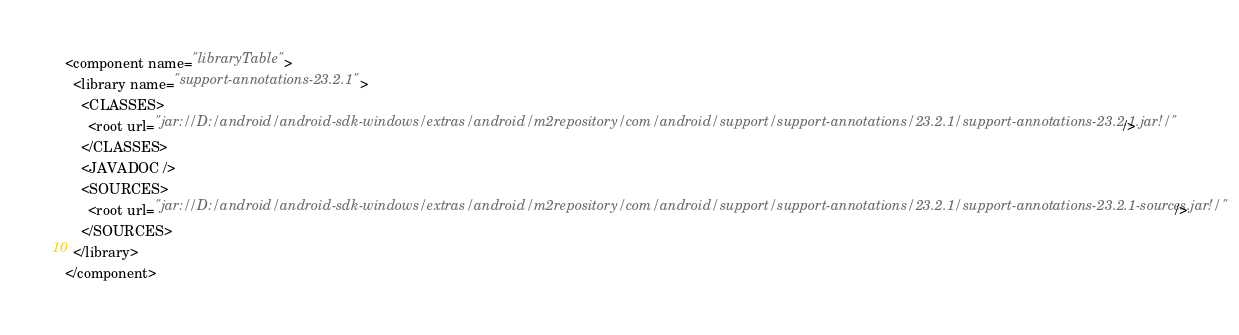Convert code to text. <code><loc_0><loc_0><loc_500><loc_500><_XML_><component name="libraryTable">
  <library name="support-annotations-23.2.1">
    <CLASSES>
      <root url="jar://D:/android/android-sdk-windows/extras/android/m2repository/com/android/support/support-annotations/23.2.1/support-annotations-23.2.1.jar!/" />
    </CLASSES>
    <JAVADOC />
    <SOURCES>
      <root url="jar://D:/android/android-sdk-windows/extras/android/m2repository/com/android/support/support-annotations/23.2.1/support-annotations-23.2.1-sources.jar!/" />
    </SOURCES>
  </library>
</component></code> 